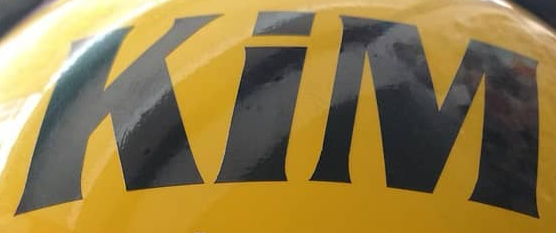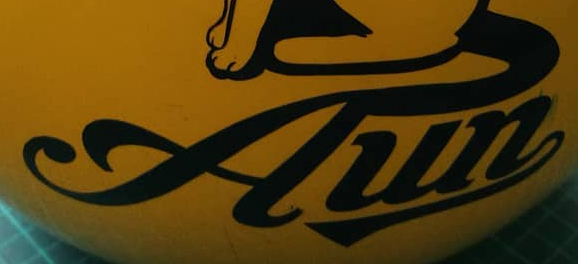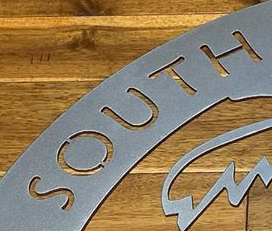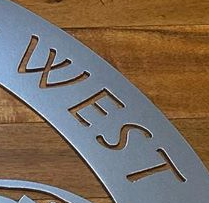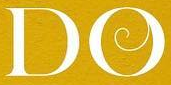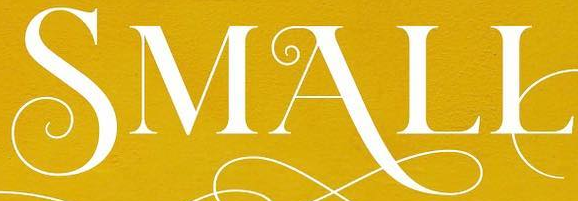What text appears in these images from left to right, separated by a semicolon? KiM; Aun; SOUTH; WEST; DO; SMALL 